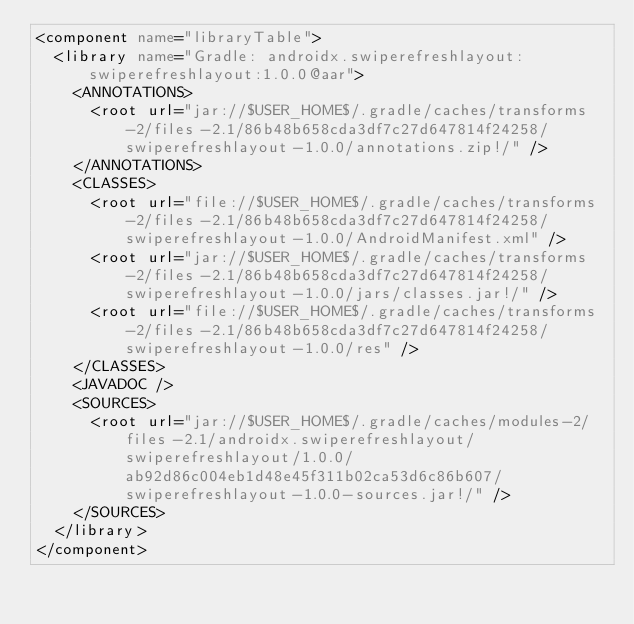<code> <loc_0><loc_0><loc_500><loc_500><_XML_><component name="libraryTable">
  <library name="Gradle: androidx.swiperefreshlayout:swiperefreshlayout:1.0.0@aar">
    <ANNOTATIONS>
      <root url="jar://$USER_HOME$/.gradle/caches/transforms-2/files-2.1/86b48b658cda3df7c27d647814f24258/swiperefreshlayout-1.0.0/annotations.zip!/" />
    </ANNOTATIONS>
    <CLASSES>
      <root url="file://$USER_HOME$/.gradle/caches/transforms-2/files-2.1/86b48b658cda3df7c27d647814f24258/swiperefreshlayout-1.0.0/AndroidManifest.xml" />
      <root url="jar://$USER_HOME$/.gradle/caches/transforms-2/files-2.1/86b48b658cda3df7c27d647814f24258/swiperefreshlayout-1.0.0/jars/classes.jar!/" />
      <root url="file://$USER_HOME$/.gradle/caches/transforms-2/files-2.1/86b48b658cda3df7c27d647814f24258/swiperefreshlayout-1.0.0/res" />
    </CLASSES>
    <JAVADOC />
    <SOURCES>
      <root url="jar://$USER_HOME$/.gradle/caches/modules-2/files-2.1/androidx.swiperefreshlayout/swiperefreshlayout/1.0.0/ab92d86c004eb1d48e45f311b02ca53d6c86b607/swiperefreshlayout-1.0.0-sources.jar!/" />
    </SOURCES>
  </library>
</component></code> 